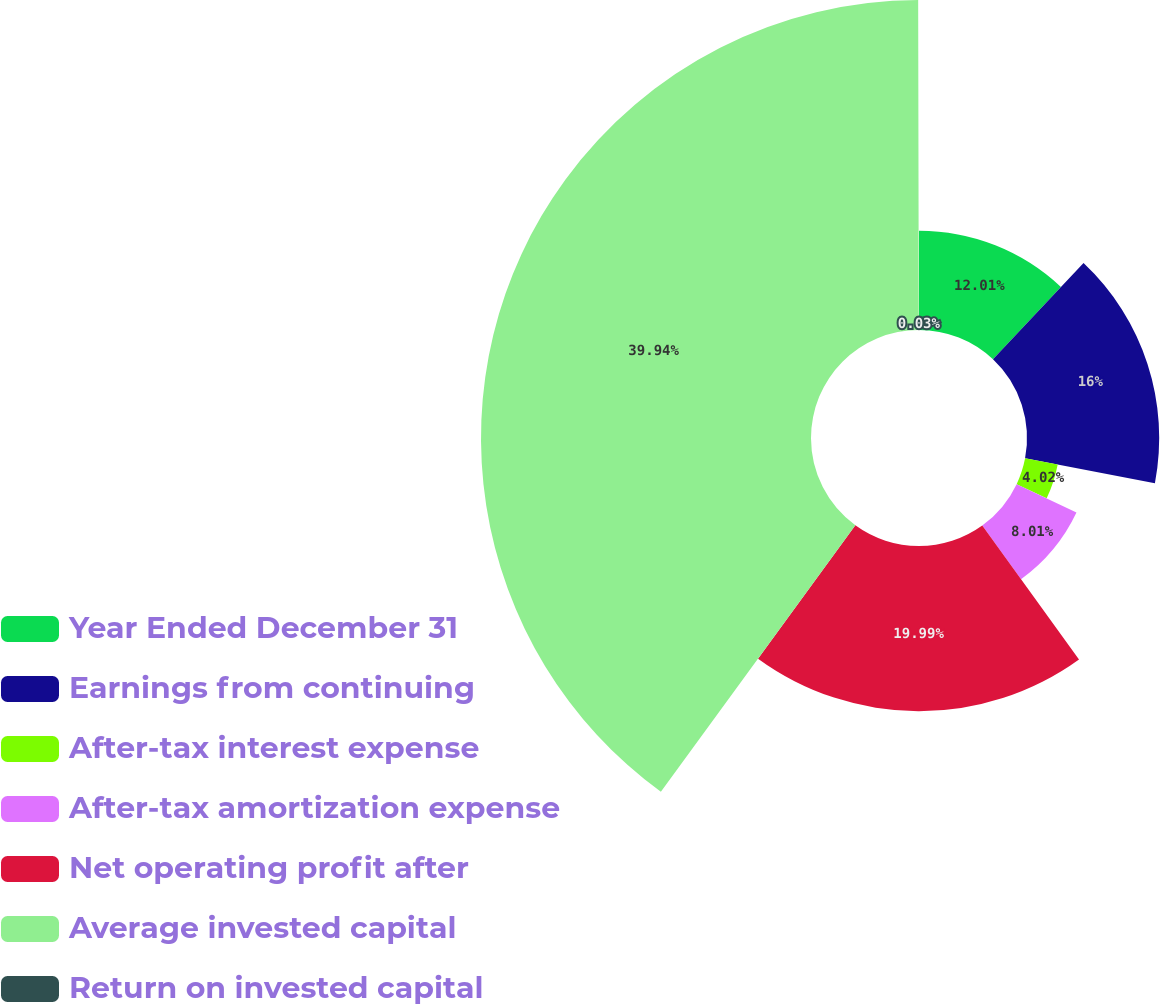Convert chart. <chart><loc_0><loc_0><loc_500><loc_500><pie_chart><fcel>Year Ended December 31<fcel>Earnings from continuing<fcel>After-tax interest expense<fcel>After-tax amortization expense<fcel>Net operating profit after<fcel>Average invested capital<fcel>Return on invested capital<nl><fcel>12.01%<fcel>16.0%<fcel>4.02%<fcel>8.01%<fcel>19.99%<fcel>39.94%<fcel>0.03%<nl></chart> 